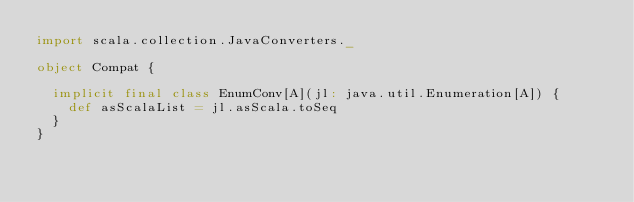Convert code to text. <code><loc_0><loc_0><loc_500><loc_500><_Scala_>import scala.collection.JavaConverters._

object Compat {

  implicit final class EnumConv[A](jl: java.util.Enumeration[A]) {
    def asScalaList = jl.asScala.toSeq
  }
}
</code> 